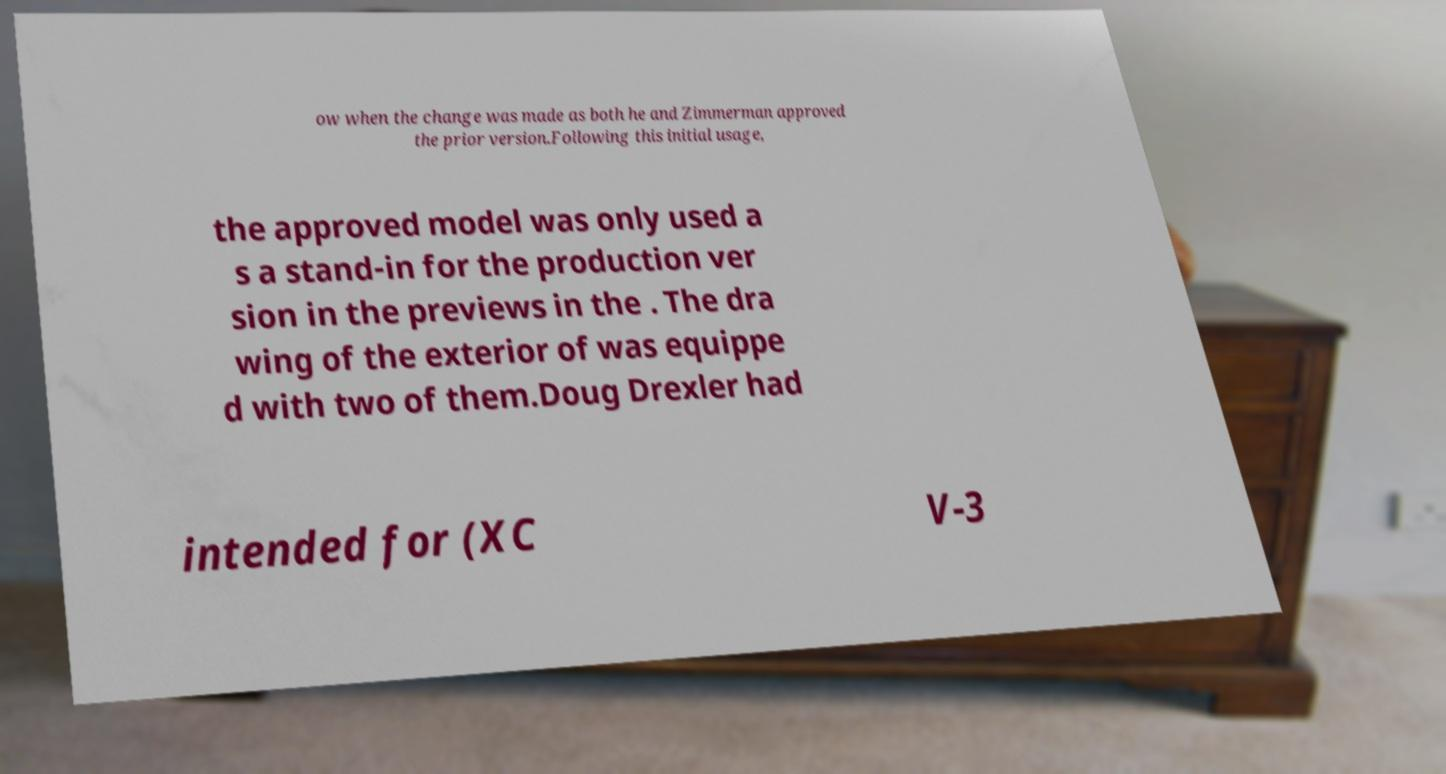For documentation purposes, I need the text within this image transcribed. Could you provide that? ow when the change was made as both he and Zimmerman approved the prior version.Following this initial usage, the approved model was only used a s a stand-in for the production ver sion in the previews in the . The dra wing of the exterior of was equippe d with two of them.Doug Drexler had intended for (XC V-3 